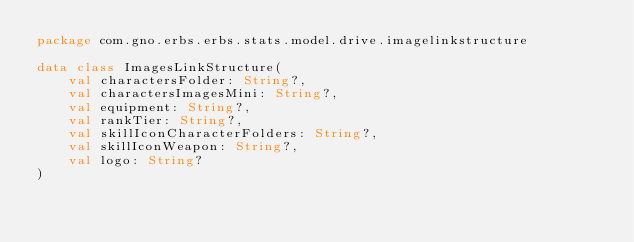Convert code to text. <code><loc_0><loc_0><loc_500><loc_500><_Kotlin_>package com.gno.erbs.erbs.stats.model.drive.imagelinkstructure

data class ImagesLinkStructure(
    val charactersFolder: String?,
    val charactersImagesMini: String?,
    val equipment: String?,
    val rankTier: String?,
    val skillIconCharacterFolders: String?,
    val skillIconWeapon: String?,
    val logo: String?
)</code> 